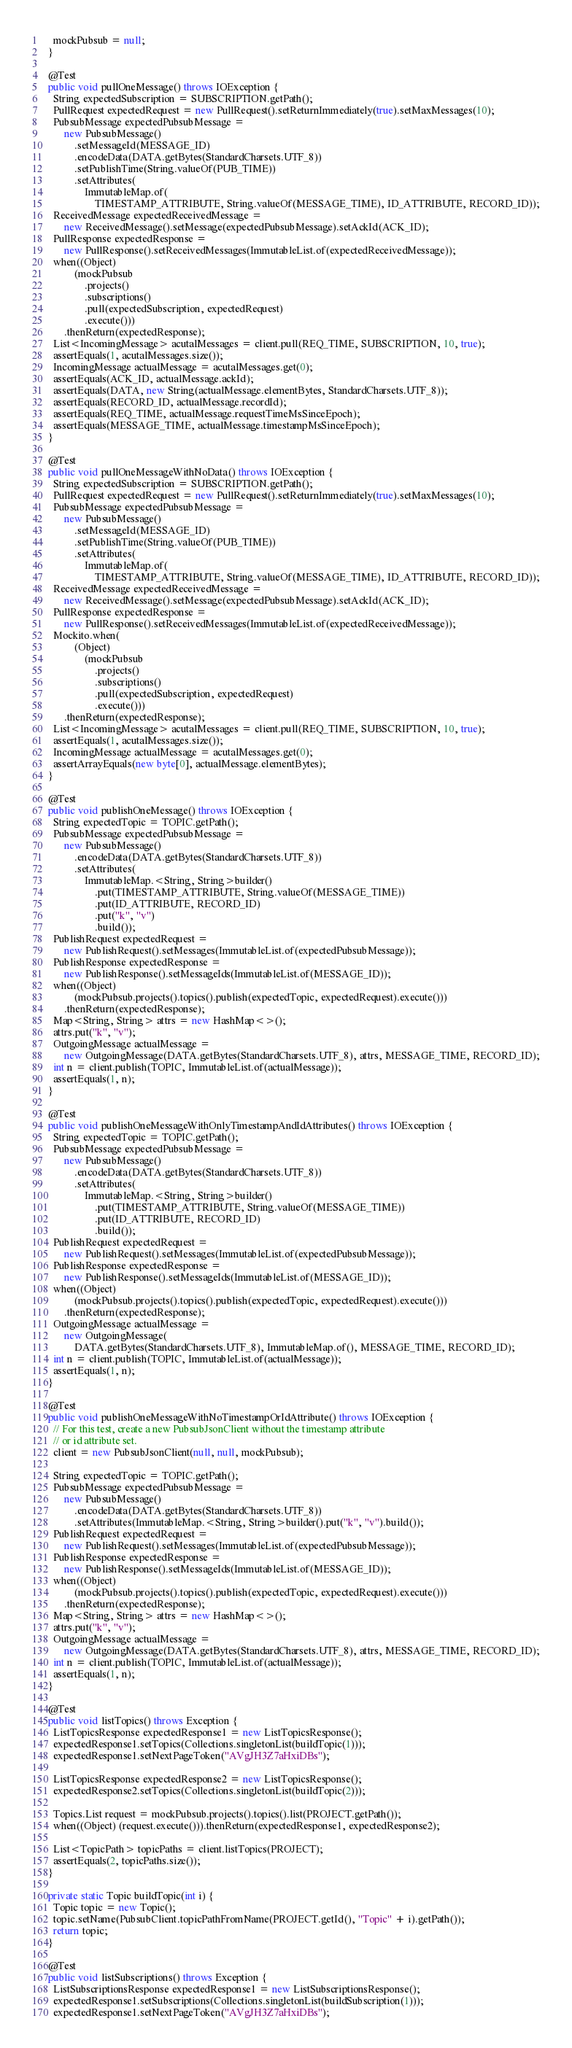<code> <loc_0><loc_0><loc_500><loc_500><_Java_>    mockPubsub = null;
  }

  @Test
  public void pullOneMessage() throws IOException {
    String expectedSubscription = SUBSCRIPTION.getPath();
    PullRequest expectedRequest = new PullRequest().setReturnImmediately(true).setMaxMessages(10);
    PubsubMessage expectedPubsubMessage =
        new PubsubMessage()
            .setMessageId(MESSAGE_ID)
            .encodeData(DATA.getBytes(StandardCharsets.UTF_8))
            .setPublishTime(String.valueOf(PUB_TIME))
            .setAttributes(
                ImmutableMap.of(
                    TIMESTAMP_ATTRIBUTE, String.valueOf(MESSAGE_TIME), ID_ATTRIBUTE, RECORD_ID));
    ReceivedMessage expectedReceivedMessage =
        new ReceivedMessage().setMessage(expectedPubsubMessage).setAckId(ACK_ID);
    PullResponse expectedResponse =
        new PullResponse().setReceivedMessages(ImmutableList.of(expectedReceivedMessage));
    when((Object)
            (mockPubsub
                .projects()
                .subscriptions()
                .pull(expectedSubscription, expectedRequest)
                .execute()))
        .thenReturn(expectedResponse);
    List<IncomingMessage> acutalMessages = client.pull(REQ_TIME, SUBSCRIPTION, 10, true);
    assertEquals(1, acutalMessages.size());
    IncomingMessage actualMessage = acutalMessages.get(0);
    assertEquals(ACK_ID, actualMessage.ackId);
    assertEquals(DATA, new String(actualMessage.elementBytes, StandardCharsets.UTF_8));
    assertEquals(RECORD_ID, actualMessage.recordId);
    assertEquals(REQ_TIME, actualMessage.requestTimeMsSinceEpoch);
    assertEquals(MESSAGE_TIME, actualMessage.timestampMsSinceEpoch);
  }

  @Test
  public void pullOneMessageWithNoData() throws IOException {
    String expectedSubscription = SUBSCRIPTION.getPath();
    PullRequest expectedRequest = new PullRequest().setReturnImmediately(true).setMaxMessages(10);
    PubsubMessage expectedPubsubMessage =
        new PubsubMessage()
            .setMessageId(MESSAGE_ID)
            .setPublishTime(String.valueOf(PUB_TIME))
            .setAttributes(
                ImmutableMap.of(
                    TIMESTAMP_ATTRIBUTE, String.valueOf(MESSAGE_TIME), ID_ATTRIBUTE, RECORD_ID));
    ReceivedMessage expectedReceivedMessage =
        new ReceivedMessage().setMessage(expectedPubsubMessage).setAckId(ACK_ID);
    PullResponse expectedResponse =
        new PullResponse().setReceivedMessages(ImmutableList.of(expectedReceivedMessage));
    Mockito.when(
            (Object)
                (mockPubsub
                    .projects()
                    .subscriptions()
                    .pull(expectedSubscription, expectedRequest)
                    .execute()))
        .thenReturn(expectedResponse);
    List<IncomingMessage> acutalMessages = client.pull(REQ_TIME, SUBSCRIPTION, 10, true);
    assertEquals(1, acutalMessages.size());
    IncomingMessage actualMessage = acutalMessages.get(0);
    assertArrayEquals(new byte[0], actualMessage.elementBytes);
  }

  @Test
  public void publishOneMessage() throws IOException {
    String expectedTopic = TOPIC.getPath();
    PubsubMessage expectedPubsubMessage =
        new PubsubMessage()
            .encodeData(DATA.getBytes(StandardCharsets.UTF_8))
            .setAttributes(
                ImmutableMap.<String, String>builder()
                    .put(TIMESTAMP_ATTRIBUTE, String.valueOf(MESSAGE_TIME))
                    .put(ID_ATTRIBUTE, RECORD_ID)
                    .put("k", "v")
                    .build());
    PublishRequest expectedRequest =
        new PublishRequest().setMessages(ImmutableList.of(expectedPubsubMessage));
    PublishResponse expectedResponse =
        new PublishResponse().setMessageIds(ImmutableList.of(MESSAGE_ID));
    when((Object)
            (mockPubsub.projects().topics().publish(expectedTopic, expectedRequest).execute()))
        .thenReturn(expectedResponse);
    Map<String, String> attrs = new HashMap<>();
    attrs.put("k", "v");
    OutgoingMessage actualMessage =
        new OutgoingMessage(DATA.getBytes(StandardCharsets.UTF_8), attrs, MESSAGE_TIME, RECORD_ID);
    int n = client.publish(TOPIC, ImmutableList.of(actualMessage));
    assertEquals(1, n);
  }

  @Test
  public void publishOneMessageWithOnlyTimestampAndIdAttributes() throws IOException {
    String expectedTopic = TOPIC.getPath();
    PubsubMessage expectedPubsubMessage =
        new PubsubMessage()
            .encodeData(DATA.getBytes(StandardCharsets.UTF_8))
            .setAttributes(
                ImmutableMap.<String, String>builder()
                    .put(TIMESTAMP_ATTRIBUTE, String.valueOf(MESSAGE_TIME))
                    .put(ID_ATTRIBUTE, RECORD_ID)
                    .build());
    PublishRequest expectedRequest =
        new PublishRequest().setMessages(ImmutableList.of(expectedPubsubMessage));
    PublishResponse expectedResponse =
        new PublishResponse().setMessageIds(ImmutableList.of(MESSAGE_ID));
    when((Object)
            (mockPubsub.projects().topics().publish(expectedTopic, expectedRequest).execute()))
        .thenReturn(expectedResponse);
    OutgoingMessage actualMessage =
        new OutgoingMessage(
            DATA.getBytes(StandardCharsets.UTF_8), ImmutableMap.of(), MESSAGE_TIME, RECORD_ID);
    int n = client.publish(TOPIC, ImmutableList.of(actualMessage));
    assertEquals(1, n);
  }

  @Test
  public void publishOneMessageWithNoTimestampOrIdAttribute() throws IOException {
    // For this test, create a new PubsubJsonClient without the timestamp attribute
    // or id attribute set.
    client = new PubsubJsonClient(null, null, mockPubsub);

    String expectedTopic = TOPIC.getPath();
    PubsubMessage expectedPubsubMessage =
        new PubsubMessage()
            .encodeData(DATA.getBytes(StandardCharsets.UTF_8))
            .setAttributes(ImmutableMap.<String, String>builder().put("k", "v").build());
    PublishRequest expectedRequest =
        new PublishRequest().setMessages(ImmutableList.of(expectedPubsubMessage));
    PublishResponse expectedResponse =
        new PublishResponse().setMessageIds(ImmutableList.of(MESSAGE_ID));
    when((Object)
            (mockPubsub.projects().topics().publish(expectedTopic, expectedRequest).execute()))
        .thenReturn(expectedResponse);
    Map<String, String> attrs = new HashMap<>();
    attrs.put("k", "v");
    OutgoingMessage actualMessage =
        new OutgoingMessage(DATA.getBytes(StandardCharsets.UTF_8), attrs, MESSAGE_TIME, RECORD_ID);
    int n = client.publish(TOPIC, ImmutableList.of(actualMessage));
    assertEquals(1, n);
  }

  @Test
  public void listTopics() throws Exception {
    ListTopicsResponse expectedResponse1 = new ListTopicsResponse();
    expectedResponse1.setTopics(Collections.singletonList(buildTopic(1)));
    expectedResponse1.setNextPageToken("AVgJH3Z7aHxiDBs");

    ListTopicsResponse expectedResponse2 = new ListTopicsResponse();
    expectedResponse2.setTopics(Collections.singletonList(buildTopic(2)));

    Topics.List request = mockPubsub.projects().topics().list(PROJECT.getPath());
    when((Object) (request.execute())).thenReturn(expectedResponse1, expectedResponse2);

    List<TopicPath> topicPaths = client.listTopics(PROJECT);
    assertEquals(2, topicPaths.size());
  }

  private static Topic buildTopic(int i) {
    Topic topic = new Topic();
    topic.setName(PubsubClient.topicPathFromName(PROJECT.getId(), "Topic" + i).getPath());
    return topic;
  }

  @Test
  public void listSubscriptions() throws Exception {
    ListSubscriptionsResponse expectedResponse1 = new ListSubscriptionsResponse();
    expectedResponse1.setSubscriptions(Collections.singletonList(buildSubscription(1)));
    expectedResponse1.setNextPageToken("AVgJH3Z7aHxiDBs");
</code> 